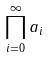<formula> <loc_0><loc_0><loc_500><loc_500>\prod _ { i = 0 } ^ { \infty } a _ { i }</formula> 